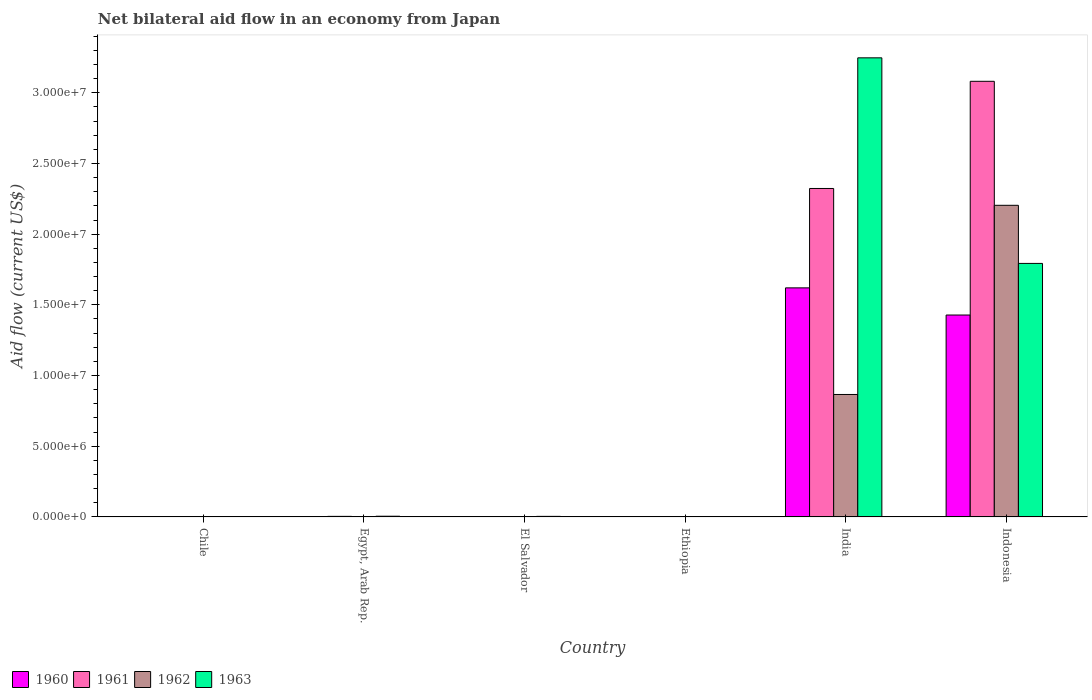How many groups of bars are there?
Provide a succinct answer. 6. How many bars are there on the 5th tick from the right?
Offer a very short reply. 4. In how many cases, is the number of bars for a given country not equal to the number of legend labels?
Make the answer very short. 0. What is the net bilateral aid flow in 1962 in El Salvador?
Give a very brief answer. 3.00e+04. Across all countries, what is the maximum net bilateral aid flow in 1961?
Offer a terse response. 3.08e+07. Across all countries, what is the minimum net bilateral aid flow in 1961?
Ensure brevity in your answer.  10000. In which country was the net bilateral aid flow in 1960 minimum?
Keep it short and to the point. Chile. What is the total net bilateral aid flow in 1963 in the graph?
Provide a succinct answer. 5.05e+07. What is the difference between the net bilateral aid flow in 1962 in Chile and that in Ethiopia?
Ensure brevity in your answer.  10000. What is the average net bilateral aid flow in 1962 per country?
Your response must be concise. 5.13e+06. In how many countries, is the net bilateral aid flow in 1961 greater than 25000000 US$?
Offer a terse response. 1. What is the ratio of the net bilateral aid flow in 1962 in Chile to that in El Salvador?
Your answer should be very brief. 0.67. What is the difference between the highest and the second highest net bilateral aid flow in 1963?
Ensure brevity in your answer.  1.45e+07. What is the difference between the highest and the lowest net bilateral aid flow in 1962?
Ensure brevity in your answer.  2.20e+07. Is the sum of the net bilateral aid flow in 1962 in El Salvador and Indonesia greater than the maximum net bilateral aid flow in 1961 across all countries?
Your answer should be compact. No. Are all the bars in the graph horizontal?
Ensure brevity in your answer.  No. Are the values on the major ticks of Y-axis written in scientific E-notation?
Give a very brief answer. Yes. Does the graph contain grids?
Give a very brief answer. No. How many legend labels are there?
Your response must be concise. 4. How are the legend labels stacked?
Provide a succinct answer. Horizontal. What is the title of the graph?
Your answer should be compact. Net bilateral aid flow in an economy from Japan. What is the label or title of the X-axis?
Keep it short and to the point. Country. What is the Aid flow (current US$) of 1961 in Egypt, Arab Rep.?
Ensure brevity in your answer.  4.00e+04. What is the Aid flow (current US$) in 1962 in Egypt, Arab Rep.?
Keep it short and to the point. 3.00e+04. What is the Aid flow (current US$) of 1962 in Ethiopia?
Your answer should be compact. 10000. What is the Aid flow (current US$) of 1960 in India?
Give a very brief answer. 1.62e+07. What is the Aid flow (current US$) in 1961 in India?
Offer a very short reply. 2.32e+07. What is the Aid flow (current US$) of 1962 in India?
Offer a very short reply. 8.66e+06. What is the Aid flow (current US$) of 1963 in India?
Provide a succinct answer. 3.25e+07. What is the Aid flow (current US$) of 1960 in Indonesia?
Ensure brevity in your answer.  1.43e+07. What is the Aid flow (current US$) of 1961 in Indonesia?
Provide a succinct answer. 3.08e+07. What is the Aid flow (current US$) in 1962 in Indonesia?
Your response must be concise. 2.20e+07. What is the Aid flow (current US$) in 1963 in Indonesia?
Your answer should be very brief. 1.79e+07. Across all countries, what is the maximum Aid flow (current US$) in 1960?
Your answer should be very brief. 1.62e+07. Across all countries, what is the maximum Aid flow (current US$) in 1961?
Provide a short and direct response. 3.08e+07. Across all countries, what is the maximum Aid flow (current US$) in 1962?
Provide a short and direct response. 2.20e+07. Across all countries, what is the maximum Aid flow (current US$) in 1963?
Your answer should be compact. 3.25e+07. Across all countries, what is the minimum Aid flow (current US$) in 1961?
Make the answer very short. 10000. Across all countries, what is the minimum Aid flow (current US$) in 1963?
Keep it short and to the point. 10000. What is the total Aid flow (current US$) of 1960 in the graph?
Ensure brevity in your answer.  3.05e+07. What is the total Aid flow (current US$) in 1961 in the graph?
Offer a very short reply. 5.41e+07. What is the total Aid flow (current US$) in 1962 in the graph?
Provide a short and direct response. 3.08e+07. What is the total Aid flow (current US$) of 1963 in the graph?
Provide a succinct answer. 5.05e+07. What is the difference between the Aid flow (current US$) of 1962 in Chile and that in El Salvador?
Your answer should be very brief. -10000. What is the difference between the Aid flow (current US$) of 1960 in Chile and that in Ethiopia?
Give a very brief answer. 0. What is the difference between the Aid flow (current US$) in 1961 in Chile and that in Ethiopia?
Give a very brief answer. 0. What is the difference between the Aid flow (current US$) in 1962 in Chile and that in Ethiopia?
Give a very brief answer. 10000. What is the difference between the Aid flow (current US$) in 1960 in Chile and that in India?
Provide a succinct answer. -1.62e+07. What is the difference between the Aid flow (current US$) of 1961 in Chile and that in India?
Make the answer very short. -2.32e+07. What is the difference between the Aid flow (current US$) of 1962 in Chile and that in India?
Your answer should be compact. -8.64e+06. What is the difference between the Aid flow (current US$) in 1963 in Chile and that in India?
Keep it short and to the point. -3.24e+07. What is the difference between the Aid flow (current US$) of 1960 in Chile and that in Indonesia?
Your answer should be compact. -1.43e+07. What is the difference between the Aid flow (current US$) of 1961 in Chile and that in Indonesia?
Make the answer very short. -3.08e+07. What is the difference between the Aid flow (current US$) in 1962 in Chile and that in Indonesia?
Provide a short and direct response. -2.20e+07. What is the difference between the Aid flow (current US$) in 1963 in Chile and that in Indonesia?
Ensure brevity in your answer.  -1.79e+07. What is the difference between the Aid flow (current US$) in 1962 in Egypt, Arab Rep. and that in El Salvador?
Give a very brief answer. 0. What is the difference between the Aid flow (current US$) in 1963 in Egypt, Arab Rep. and that in El Salvador?
Keep it short and to the point. 10000. What is the difference between the Aid flow (current US$) of 1961 in Egypt, Arab Rep. and that in Ethiopia?
Make the answer very short. 3.00e+04. What is the difference between the Aid flow (current US$) in 1963 in Egypt, Arab Rep. and that in Ethiopia?
Provide a short and direct response. 4.00e+04. What is the difference between the Aid flow (current US$) in 1960 in Egypt, Arab Rep. and that in India?
Make the answer very short. -1.62e+07. What is the difference between the Aid flow (current US$) of 1961 in Egypt, Arab Rep. and that in India?
Provide a short and direct response. -2.32e+07. What is the difference between the Aid flow (current US$) of 1962 in Egypt, Arab Rep. and that in India?
Keep it short and to the point. -8.63e+06. What is the difference between the Aid flow (current US$) in 1963 in Egypt, Arab Rep. and that in India?
Your answer should be compact. -3.24e+07. What is the difference between the Aid flow (current US$) of 1960 in Egypt, Arab Rep. and that in Indonesia?
Ensure brevity in your answer.  -1.42e+07. What is the difference between the Aid flow (current US$) of 1961 in Egypt, Arab Rep. and that in Indonesia?
Provide a short and direct response. -3.08e+07. What is the difference between the Aid flow (current US$) in 1962 in Egypt, Arab Rep. and that in Indonesia?
Provide a succinct answer. -2.20e+07. What is the difference between the Aid flow (current US$) of 1963 in Egypt, Arab Rep. and that in Indonesia?
Ensure brevity in your answer.  -1.79e+07. What is the difference between the Aid flow (current US$) in 1960 in El Salvador and that in Ethiopia?
Your answer should be very brief. 0. What is the difference between the Aid flow (current US$) in 1962 in El Salvador and that in Ethiopia?
Your answer should be compact. 2.00e+04. What is the difference between the Aid flow (current US$) in 1963 in El Salvador and that in Ethiopia?
Ensure brevity in your answer.  3.00e+04. What is the difference between the Aid flow (current US$) of 1960 in El Salvador and that in India?
Offer a terse response. -1.62e+07. What is the difference between the Aid flow (current US$) in 1961 in El Salvador and that in India?
Give a very brief answer. -2.32e+07. What is the difference between the Aid flow (current US$) in 1962 in El Salvador and that in India?
Provide a short and direct response. -8.63e+06. What is the difference between the Aid flow (current US$) of 1963 in El Salvador and that in India?
Your answer should be compact. -3.24e+07. What is the difference between the Aid flow (current US$) in 1960 in El Salvador and that in Indonesia?
Your answer should be compact. -1.43e+07. What is the difference between the Aid flow (current US$) of 1961 in El Salvador and that in Indonesia?
Make the answer very short. -3.08e+07. What is the difference between the Aid flow (current US$) in 1962 in El Salvador and that in Indonesia?
Provide a short and direct response. -2.20e+07. What is the difference between the Aid flow (current US$) of 1963 in El Salvador and that in Indonesia?
Your answer should be very brief. -1.79e+07. What is the difference between the Aid flow (current US$) of 1960 in Ethiopia and that in India?
Your answer should be compact. -1.62e+07. What is the difference between the Aid flow (current US$) of 1961 in Ethiopia and that in India?
Provide a succinct answer. -2.32e+07. What is the difference between the Aid flow (current US$) in 1962 in Ethiopia and that in India?
Give a very brief answer. -8.65e+06. What is the difference between the Aid flow (current US$) of 1963 in Ethiopia and that in India?
Provide a short and direct response. -3.25e+07. What is the difference between the Aid flow (current US$) in 1960 in Ethiopia and that in Indonesia?
Make the answer very short. -1.43e+07. What is the difference between the Aid flow (current US$) in 1961 in Ethiopia and that in Indonesia?
Make the answer very short. -3.08e+07. What is the difference between the Aid flow (current US$) in 1962 in Ethiopia and that in Indonesia?
Your response must be concise. -2.20e+07. What is the difference between the Aid flow (current US$) of 1963 in Ethiopia and that in Indonesia?
Give a very brief answer. -1.79e+07. What is the difference between the Aid flow (current US$) in 1960 in India and that in Indonesia?
Offer a terse response. 1.92e+06. What is the difference between the Aid flow (current US$) in 1961 in India and that in Indonesia?
Ensure brevity in your answer.  -7.58e+06. What is the difference between the Aid flow (current US$) of 1962 in India and that in Indonesia?
Your response must be concise. -1.34e+07. What is the difference between the Aid flow (current US$) in 1963 in India and that in Indonesia?
Offer a very short reply. 1.45e+07. What is the difference between the Aid flow (current US$) in 1960 in Chile and the Aid flow (current US$) in 1961 in Egypt, Arab Rep.?
Offer a very short reply. -3.00e+04. What is the difference between the Aid flow (current US$) in 1960 in Chile and the Aid flow (current US$) in 1963 in Egypt, Arab Rep.?
Provide a succinct answer. -4.00e+04. What is the difference between the Aid flow (current US$) in 1961 in Chile and the Aid flow (current US$) in 1962 in Egypt, Arab Rep.?
Ensure brevity in your answer.  -2.00e+04. What is the difference between the Aid flow (current US$) of 1960 in Chile and the Aid flow (current US$) of 1961 in El Salvador?
Provide a succinct answer. 0. What is the difference between the Aid flow (current US$) of 1960 in Chile and the Aid flow (current US$) of 1962 in El Salvador?
Your response must be concise. -2.00e+04. What is the difference between the Aid flow (current US$) in 1961 in Chile and the Aid flow (current US$) in 1963 in El Salvador?
Provide a short and direct response. -3.00e+04. What is the difference between the Aid flow (current US$) of 1960 in Chile and the Aid flow (current US$) of 1961 in Ethiopia?
Ensure brevity in your answer.  0. What is the difference between the Aid flow (current US$) in 1960 in Chile and the Aid flow (current US$) in 1962 in Ethiopia?
Your response must be concise. 0. What is the difference between the Aid flow (current US$) in 1960 in Chile and the Aid flow (current US$) in 1963 in Ethiopia?
Offer a very short reply. 0. What is the difference between the Aid flow (current US$) of 1961 in Chile and the Aid flow (current US$) of 1962 in Ethiopia?
Offer a terse response. 0. What is the difference between the Aid flow (current US$) in 1962 in Chile and the Aid flow (current US$) in 1963 in Ethiopia?
Offer a terse response. 10000. What is the difference between the Aid flow (current US$) of 1960 in Chile and the Aid flow (current US$) of 1961 in India?
Your answer should be compact. -2.32e+07. What is the difference between the Aid flow (current US$) in 1960 in Chile and the Aid flow (current US$) in 1962 in India?
Your response must be concise. -8.65e+06. What is the difference between the Aid flow (current US$) in 1960 in Chile and the Aid flow (current US$) in 1963 in India?
Provide a succinct answer. -3.25e+07. What is the difference between the Aid flow (current US$) of 1961 in Chile and the Aid flow (current US$) of 1962 in India?
Give a very brief answer. -8.65e+06. What is the difference between the Aid flow (current US$) of 1961 in Chile and the Aid flow (current US$) of 1963 in India?
Make the answer very short. -3.25e+07. What is the difference between the Aid flow (current US$) of 1962 in Chile and the Aid flow (current US$) of 1963 in India?
Provide a succinct answer. -3.24e+07. What is the difference between the Aid flow (current US$) of 1960 in Chile and the Aid flow (current US$) of 1961 in Indonesia?
Give a very brief answer. -3.08e+07. What is the difference between the Aid flow (current US$) in 1960 in Chile and the Aid flow (current US$) in 1962 in Indonesia?
Keep it short and to the point. -2.20e+07. What is the difference between the Aid flow (current US$) of 1960 in Chile and the Aid flow (current US$) of 1963 in Indonesia?
Offer a very short reply. -1.79e+07. What is the difference between the Aid flow (current US$) of 1961 in Chile and the Aid flow (current US$) of 1962 in Indonesia?
Give a very brief answer. -2.20e+07. What is the difference between the Aid flow (current US$) of 1961 in Chile and the Aid flow (current US$) of 1963 in Indonesia?
Your answer should be compact. -1.79e+07. What is the difference between the Aid flow (current US$) of 1962 in Chile and the Aid flow (current US$) of 1963 in Indonesia?
Your answer should be compact. -1.79e+07. What is the difference between the Aid flow (current US$) of 1960 in Egypt, Arab Rep. and the Aid flow (current US$) of 1961 in El Salvador?
Ensure brevity in your answer.  2.00e+04. What is the difference between the Aid flow (current US$) in 1961 in Egypt, Arab Rep. and the Aid flow (current US$) in 1963 in El Salvador?
Make the answer very short. 0. What is the difference between the Aid flow (current US$) in 1962 in Egypt, Arab Rep. and the Aid flow (current US$) in 1963 in El Salvador?
Give a very brief answer. -10000. What is the difference between the Aid flow (current US$) of 1960 in Egypt, Arab Rep. and the Aid flow (current US$) of 1961 in Ethiopia?
Your answer should be compact. 2.00e+04. What is the difference between the Aid flow (current US$) of 1961 in Egypt, Arab Rep. and the Aid flow (current US$) of 1962 in Ethiopia?
Keep it short and to the point. 3.00e+04. What is the difference between the Aid flow (current US$) in 1962 in Egypt, Arab Rep. and the Aid flow (current US$) in 1963 in Ethiopia?
Provide a succinct answer. 2.00e+04. What is the difference between the Aid flow (current US$) of 1960 in Egypt, Arab Rep. and the Aid flow (current US$) of 1961 in India?
Give a very brief answer. -2.32e+07. What is the difference between the Aid flow (current US$) in 1960 in Egypt, Arab Rep. and the Aid flow (current US$) in 1962 in India?
Give a very brief answer. -8.63e+06. What is the difference between the Aid flow (current US$) in 1960 in Egypt, Arab Rep. and the Aid flow (current US$) in 1963 in India?
Ensure brevity in your answer.  -3.24e+07. What is the difference between the Aid flow (current US$) in 1961 in Egypt, Arab Rep. and the Aid flow (current US$) in 1962 in India?
Provide a succinct answer. -8.62e+06. What is the difference between the Aid flow (current US$) of 1961 in Egypt, Arab Rep. and the Aid flow (current US$) of 1963 in India?
Keep it short and to the point. -3.24e+07. What is the difference between the Aid flow (current US$) of 1962 in Egypt, Arab Rep. and the Aid flow (current US$) of 1963 in India?
Make the answer very short. -3.24e+07. What is the difference between the Aid flow (current US$) in 1960 in Egypt, Arab Rep. and the Aid flow (current US$) in 1961 in Indonesia?
Your response must be concise. -3.08e+07. What is the difference between the Aid flow (current US$) in 1960 in Egypt, Arab Rep. and the Aid flow (current US$) in 1962 in Indonesia?
Ensure brevity in your answer.  -2.20e+07. What is the difference between the Aid flow (current US$) in 1960 in Egypt, Arab Rep. and the Aid flow (current US$) in 1963 in Indonesia?
Give a very brief answer. -1.79e+07. What is the difference between the Aid flow (current US$) of 1961 in Egypt, Arab Rep. and the Aid flow (current US$) of 1962 in Indonesia?
Ensure brevity in your answer.  -2.20e+07. What is the difference between the Aid flow (current US$) of 1961 in Egypt, Arab Rep. and the Aid flow (current US$) of 1963 in Indonesia?
Ensure brevity in your answer.  -1.79e+07. What is the difference between the Aid flow (current US$) of 1962 in Egypt, Arab Rep. and the Aid flow (current US$) of 1963 in Indonesia?
Offer a very short reply. -1.79e+07. What is the difference between the Aid flow (current US$) of 1961 in El Salvador and the Aid flow (current US$) of 1963 in Ethiopia?
Provide a short and direct response. 0. What is the difference between the Aid flow (current US$) of 1962 in El Salvador and the Aid flow (current US$) of 1963 in Ethiopia?
Offer a terse response. 2.00e+04. What is the difference between the Aid flow (current US$) of 1960 in El Salvador and the Aid flow (current US$) of 1961 in India?
Your answer should be compact. -2.32e+07. What is the difference between the Aid flow (current US$) of 1960 in El Salvador and the Aid flow (current US$) of 1962 in India?
Give a very brief answer. -8.65e+06. What is the difference between the Aid flow (current US$) of 1960 in El Salvador and the Aid flow (current US$) of 1963 in India?
Your response must be concise. -3.25e+07. What is the difference between the Aid flow (current US$) in 1961 in El Salvador and the Aid flow (current US$) in 1962 in India?
Ensure brevity in your answer.  -8.65e+06. What is the difference between the Aid flow (current US$) of 1961 in El Salvador and the Aid flow (current US$) of 1963 in India?
Make the answer very short. -3.25e+07. What is the difference between the Aid flow (current US$) in 1962 in El Salvador and the Aid flow (current US$) in 1963 in India?
Your response must be concise. -3.24e+07. What is the difference between the Aid flow (current US$) of 1960 in El Salvador and the Aid flow (current US$) of 1961 in Indonesia?
Offer a very short reply. -3.08e+07. What is the difference between the Aid flow (current US$) of 1960 in El Salvador and the Aid flow (current US$) of 1962 in Indonesia?
Provide a succinct answer. -2.20e+07. What is the difference between the Aid flow (current US$) in 1960 in El Salvador and the Aid flow (current US$) in 1963 in Indonesia?
Make the answer very short. -1.79e+07. What is the difference between the Aid flow (current US$) of 1961 in El Salvador and the Aid flow (current US$) of 1962 in Indonesia?
Your response must be concise. -2.20e+07. What is the difference between the Aid flow (current US$) of 1961 in El Salvador and the Aid flow (current US$) of 1963 in Indonesia?
Offer a terse response. -1.79e+07. What is the difference between the Aid flow (current US$) of 1962 in El Salvador and the Aid flow (current US$) of 1963 in Indonesia?
Make the answer very short. -1.79e+07. What is the difference between the Aid flow (current US$) of 1960 in Ethiopia and the Aid flow (current US$) of 1961 in India?
Your response must be concise. -2.32e+07. What is the difference between the Aid flow (current US$) in 1960 in Ethiopia and the Aid flow (current US$) in 1962 in India?
Offer a terse response. -8.65e+06. What is the difference between the Aid flow (current US$) in 1960 in Ethiopia and the Aid flow (current US$) in 1963 in India?
Make the answer very short. -3.25e+07. What is the difference between the Aid flow (current US$) in 1961 in Ethiopia and the Aid flow (current US$) in 1962 in India?
Provide a short and direct response. -8.65e+06. What is the difference between the Aid flow (current US$) in 1961 in Ethiopia and the Aid flow (current US$) in 1963 in India?
Offer a very short reply. -3.25e+07. What is the difference between the Aid flow (current US$) in 1962 in Ethiopia and the Aid flow (current US$) in 1963 in India?
Ensure brevity in your answer.  -3.25e+07. What is the difference between the Aid flow (current US$) in 1960 in Ethiopia and the Aid flow (current US$) in 1961 in Indonesia?
Offer a terse response. -3.08e+07. What is the difference between the Aid flow (current US$) in 1960 in Ethiopia and the Aid flow (current US$) in 1962 in Indonesia?
Your response must be concise. -2.20e+07. What is the difference between the Aid flow (current US$) of 1960 in Ethiopia and the Aid flow (current US$) of 1963 in Indonesia?
Provide a succinct answer. -1.79e+07. What is the difference between the Aid flow (current US$) in 1961 in Ethiopia and the Aid flow (current US$) in 1962 in Indonesia?
Ensure brevity in your answer.  -2.20e+07. What is the difference between the Aid flow (current US$) of 1961 in Ethiopia and the Aid flow (current US$) of 1963 in Indonesia?
Your answer should be compact. -1.79e+07. What is the difference between the Aid flow (current US$) in 1962 in Ethiopia and the Aid flow (current US$) in 1963 in Indonesia?
Your answer should be compact. -1.79e+07. What is the difference between the Aid flow (current US$) in 1960 in India and the Aid flow (current US$) in 1961 in Indonesia?
Offer a very short reply. -1.46e+07. What is the difference between the Aid flow (current US$) in 1960 in India and the Aid flow (current US$) in 1962 in Indonesia?
Offer a very short reply. -5.84e+06. What is the difference between the Aid flow (current US$) of 1960 in India and the Aid flow (current US$) of 1963 in Indonesia?
Your answer should be compact. -1.73e+06. What is the difference between the Aid flow (current US$) of 1961 in India and the Aid flow (current US$) of 1962 in Indonesia?
Provide a succinct answer. 1.19e+06. What is the difference between the Aid flow (current US$) in 1961 in India and the Aid flow (current US$) in 1963 in Indonesia?
Your response must be concise. 5.30e+06. What is the difference between the Aid flow (current US$) of 1962 in India and the Aid flow (current US$) of 1963 in Indonesia?
Make the answer very short. -9.27e+06. What is the average Aid flow (current US$) in 1960 per country?
Provide a short and direct response. 5.09e+06. What is the average Aid flow (current US$) in 1961 per country?
Offer a terse response. 9.02e+06. What is the average Aid flow (current US$) of 1962 per country?
Offer a very short reply. 5.13e+06. What is the average Aid flow (current US$) of 1963 per country?
Your answer should be compact. 8.42e+06. What is the difference between the Aid flow (current US$) of 1960 and Aid flow (current US$) of 1961 in Chile?
Keep it short and to the point. 0. What is the difference between the Aid flow (current US$) of 1962 and Aid flow (current US$) of 1963 in Egypt, Arab Rep.?
Keep it short and to the point. -2.00e+04. What is the difference between the Aid flow (current US$) in 1960 and Aid flow (current US$) in 1962 in El Salvador?
Offer a very short reply. -2.00e+04. What is the difference between the Aid flow (current US$) of 1960 and Aid flow (current US$) of 1963 in El Salvador?
Give a very brief answer. -3.00e+04. What is the difference between the Aid flow (current US$) of 1961 and Aid flow (current US$) of 1962 in El Salvador?
Provide a succinct answer. -2.00e+04. What is the difference between the Aid flow (current US$) in 1960 and Aid flow (current US$) in 1962 in Ethiopia?
Your answer should be very brief. 0. What is the difference between the Aid flow (current US$) of 1960 and Aid flow (current US$) of 1963 in Ethiopia?
Your answer should be very brief. 0. What is the difference between the Aid flow (current US$) in 1962 and Aid flow (current US$) in 1963 in Ethiopia?
Provide a succinct answer. 0. What is the difference between the Aid flow (current US$) in 1960 and Aid flow (current US$) in 1961 in India?
Keep it short and to the point. -7.03e+06. What is the difference between the Aid flow (current US$) of 1960 and Aid flow (current US$) of 1962 in India?
Provide a succinct answer. 7.54e+06. What is the difference between the Aid flow (current US$) in 1960 and Aid flow (current US$) in 1963 in India?
Keep it short and to the point. -1.63e+07. What is the difference between the Aid flow (current US$) in 1961 and Aid flow (current US$) in 1962 in India?
Offer a very short reply. 1.46e+07. What is the difference between the Aid flow (current US$) of 1961 and Aid flow (current US$) of 1963 in India?
Your answer should be very brief. -9.24e+06. What is the difference between the Aid flow (current US$) in 1962 and Aid flow (current US$) in 1963 in India?
Provide a short and direct response. -2.38e+07. What is the difference between the Aid flow (current US$) of 1960 and Aid flow (current US$) of 1961 in Indonesia?
Offer a terse response. -1.65e+07. What is the difference between the Aid flow (current US$) in 1960 and Aid flow (current US$) in 1962 in Indonesia?
Make the answer very short. -7.76e+06. What is the difference between the Aid flow (current US$) of 1960 and Aid flow (current US$) of 1963 in Indonesia?
Your response must be concise. -3.65e+06. What is the difference between the Aid flow (current US$) of 1961 and Aid flow (current US$) of 1962 in Indonesia?
Provide a succinct answer. 8.77e+06. What is the difference between the Aid flow (current US$) in 1961 and Aid flow (current US$) in 1963 in Indonesia?
Offer a very short reply. 1.29e+07. What is the difference between the Aid flow (current US$) of 1962 and Aid flow (current US$) of 1963 in Indonesia?
Your answer should be compact. 4.11e+06. What is the ratio of the Aid flow (current US$) in 1961 in Chile to that in Egypt, Arab Rep.?
Give a very brief answer. 0.25. What is the ratio of the Aid flow (current US$) of 1963 in Chile to that in El Salvador?
Your response must be concise. 0.75. What is the ratio of the Aid flow (current US$) in 1960 in Chile to that in Ethiopia?
Offer a terse response. 1. What is the ratio of the Aid flow (current US$) of 1961 in Chile to that in Ethiopia?
Provide a succinct answer. 1. What is the ratio of the Aid flow (current US$) of 1963 in Chile to that in Ethiopia?
Provide a succinct answer. 3. What is the ratio of the Aid flow (current US$) in 1960 in Chile to that in India?
Provide a short and direct response. 0. What is the ratio of the Aid flow (current US$) of 1961 in Chile to that in India?
Provide a succinct answer. 0. What is the ratio of the Aid flow (current US$) in 1962 in Chile to that in India?
Provide a succinct answer. 0. What is the ratio of the Aid flow (current US$) in 1963 in Chile to that in India?
Your answer should be compact. 0. What is the ratio of the Aid flow (current US$) of 1960 in Chile to that in Indonesia?
Offer a very short reply. 0. What is the ratio of the Aid flow (current US$) of 1962 in Chile to that in Indonesia?
Your answer should be compact. 0. What is the ratio of the Aid flow (current US$) of 1963 in Chile to that in Indonesia?
Offer a terse response. 0. What is the ratio of the Aid flow (current US$) of 1962 in Egypt, Arab Rep. to that in El Salvador?
Your answer should be compact. 1. What is the ratio of the Aid flow (current US$) of 1961 in Egypt, Arab Rep. to that in Ethiopia?
Keep it short and to the point. 4. What is the ratio of the Aid flow (current US$) in 1960 in Egypt, Arab Rep. to that in India?
Make the answer very short. 0. What is the ratio of the Aid flow (current US$) in 1961 in Egypt, Arab Rep. to that in India?
Offer a terse response. 0. What is the ratio of the Aid flow (current US$) of 1962 in Egypt, Arab Rep. to that in India?
Your answer should be very brief. 0. What is the ratio of the Aid flow (current US$) in 1963 in Egypt, Arab Rep. to that in India?
Your answer should be very brief. 0. What is the ratio of the Aid flow (current US$) in 1960 in Egypt, Arab Rep. to that in Indonesia?
Keep it short and to the point. 0. What is the ratio of the Aid flow (current US$) in 1961 in Egypt, Arab Rep. to that in Indonesia?
Ensure brevity in your answer.  0. What is the ratio of the Aid flow (current US$) of 1962 in Egypt, Arab Rep. to that in Indonesia?
Offer a terse response. 0. What is the ratio of the Aid flow (current US$) of 1963 in Egypt, Arab Rep. to that in Indonesia?
Provide a short and direct response. 0. What is the ratio of the Aid flow (current US$) in 1960 in El Salvador to that in Ethiopia?
Your answer should be very brief. 1. What is the ratio of the Aid flow (current US$) in 1961 in El Salvador to that in Ethiopia?
Make the answer very short. 1. What is the ratio of the Aid flow (current US$) in 1960 in El Salvador to that in India?
Provide a short and direct response. 0. What is the ratio of the Aid flow (current US$) of 1961 in El Salvador to that in India?
Keep it short and to the point. 0. What is the ratio of the Aid flow (current US$) in 1962 in El Salvador to that in India?
Keep it short and to the point. 0. What is the ratio of the Aid flow (current US$) of 1963 in El Salvador to that in India?
Keep it short and to the point. 0. What is the ratio of the Aid flow (current US$) of 1960 in El Salvador to that in Indonesia?
Provide a short and direct response. 0. What is the ratio of the Aid flow (current US$) of 1961 in El Salvador to that in Indonesia?
Provide a short and direct response. 0. What is the ratio of the Aid flow (current US$) in 1962 in El Salvador to that in Indonesia?
Your answer should be compact. 0. What is the ratio of the Aid flow (current US$) in 1963 in El Salvador to that in Indonesia?
Provide a short and direct response. 0. What is the ratio of the Aid flow (current US$) in 1960 in Ethiopia to that in India?
Provide a short and direct response. 0. What is the ratio of the Aid flow (current US$) in 1961 in Ethiopia to that in India?
Give a very brief answer. 0. What is the ratio of the Aid flow (current US$) of 1962 in Ethiopia to that in India?
Offer a very short reply. 0. What is the ratio of the Aid flow (current US$) of 1960 in Ethiopia to that in Indonesia?
Keep it short and to the point. 0. What is the ratio of the Aid flow (current US$) in 1961 in Ethiopia to that in Indonesia?
Keep it short and to the point. 0. What is the ratio of the Aid flow (current US$) in 1962 in Ethiopia to that in Indonesia?
Offer a terse response. 0. What is the ratio of the Aid flow (current US$) in 1963 in Ethiopia to that in Indonesia?
Make the answer very short. 0. What is the ratio of the Aid flow (current US$) in 1960 in India to that in Indonesia?
Make the answer very short. 1.13. What is the ratio of the Aid flow (current US$) in 1961 in India to that in Indonesia?
Your answer should be very brief. 0.75. What is the ratio of the Aid flow (current US$) of 1962 in India to that in Indonesia?
Ensure brevity in your answer.  0.39. What is the ratio of the Aid flow (current US$) in 1963 in India to that in Indonesia?
Keep it short and to the point. 1.81. What is the difference between the highest and the second highest Aid flow (current US$) of 1960?
Provide a succinct answer. 1.92e+06. What is the difference between the highest and the second highest Aid flow (current US$) in 1961?
Make the answer very short. 7.58e+06. What is the difference between the highest and the second highest Aid flow (current US$) in 1962?
Ensure brevity in your answer.  1.34e+07. What is the difference between the highest and the second highest Aid flow (current US$) of 1963?
Ensure brevity in your answer.  1.45e+07. What is the difference between the highest and the lowest Aid flow (current US$) of 1960?
Your response must be concise. 1.62e+07. What is the difference between the highest and the lowest Aid flow (current US$) in 1961?
Offer a terse response. 3.08e+07. What is the difference between the highest and the lowest Aid flow (current US$) in 1962?
Your answer should be compact. 2.20e+07. What is the difference between the highest and the lowest Aid flow (current US$) in 1963?
Make the answer very short. 3.25e+07. 